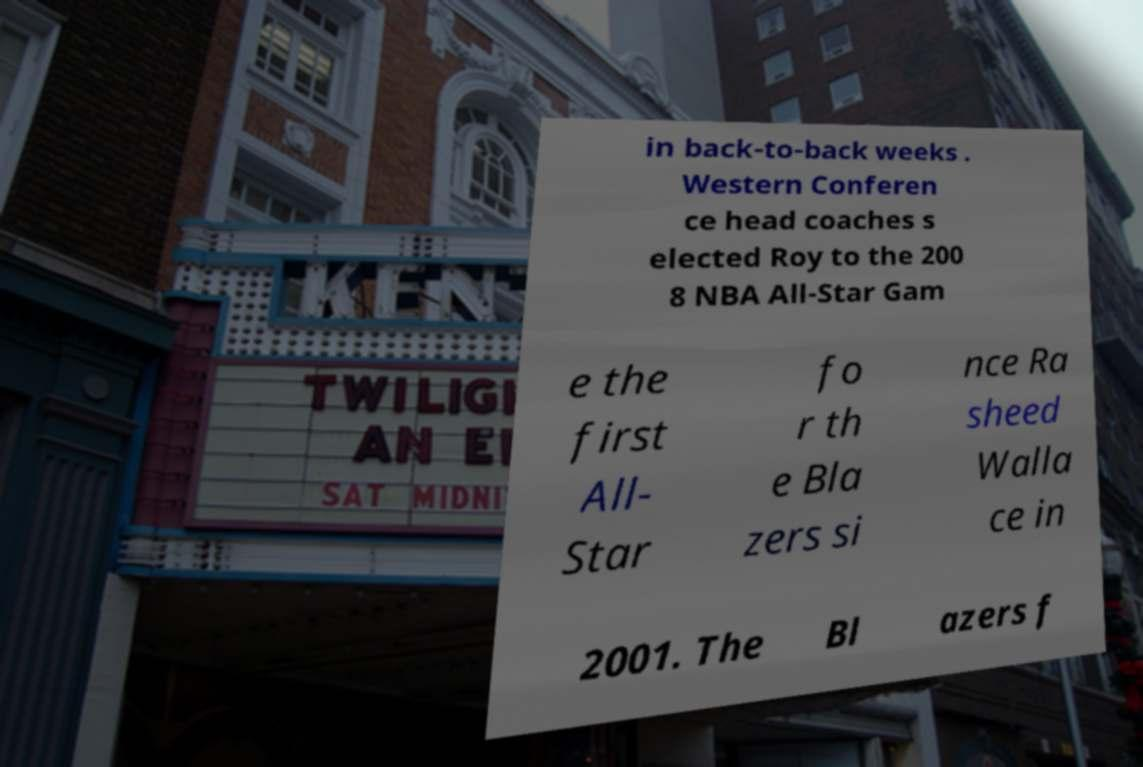For documentation purposes, I need the text within this image transcribed. Could you provide that? in back-to-back weeks . Western Conferen ce head coaches s elected Roy to the 200 8 NBA All-Star Gam e the first All- Star fo r th e Bla zers si nce Ra sheed Walla ce in 2001. The Bl azers f 